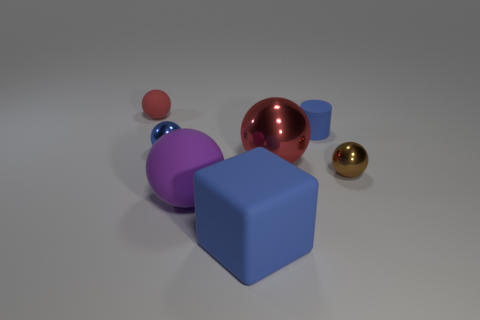Subtract all red balls. How many were subtracted if there are1red balls left? 1 Subtract all red spheres. How many spheres are left? 3 Add 2 big green things. How many objects exist? 9 Subtract 1 cubes. How many cubes are left? 0 Subtract all green cylinders. How many red balls are left? 2 Subtract all cylinders. How many objects are left? 6 Subtract all purple balls. How many balls are left? 4 Subtract all purple blocks. Subtract all gray cylinders. How many blocks are left? 1 Subtract all cylinders. Subtract all small blue rubber things. How many objects are left? 5 Add 2 matte balls. How many matte balls are left? 4 